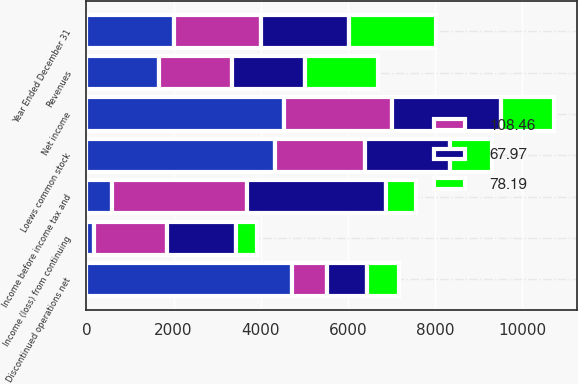Convert chart to OTSL. <chart><loc_0><loc_0><loc_500><loc_500><stacked_bar_chart><ecel><fcel>Year Ended December 31<fcel>Revenues<fcel>Income before income tax and<fcel>Income (loss) from continuing<fcel>Discontinued operations net<fcel>Net income<fcel>Loews common stock<nl><fcel>nan<fcel>2008<fcel>1676<fcel>587<fcel>182<fcel>4712<fcel>4530<fcel>4319<nl><fcel>67.97<fcel>2007<fcel>1676<fcel>3195<fcel>1587<fcel>902<fcel>2489<fcel>1956<nl><fcel>108.46<fcel>2006<fcel>1676<fcel>3104<fcel>1676<fcel>815<fcel>2491<fcel>2075<nl><fcel>78.19<fcel>2005<fcel>1676<fcel>676<fcel>475<fcel>737<fcel>1212<fcel>961<nl></chart> 